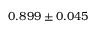<formula> <loc_0><loc_0><loc_500><loc_500>0 . 8 9 9 \pm 0 . 0 4 5</formula> 